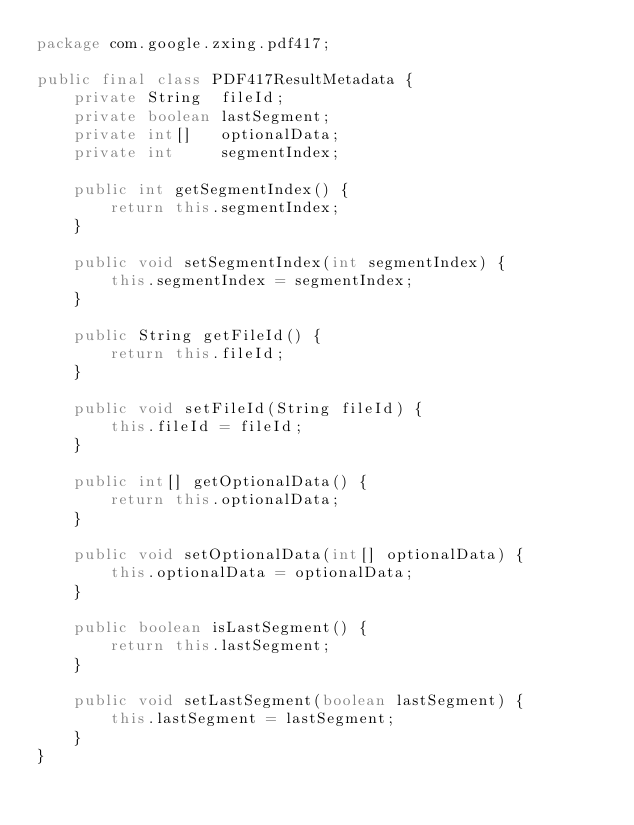Convert code to text. <code><loc_0><loc_0><loc_500><loc_500><_Java_>package com.google.zxing.pdf417;

public final class PDF417ResultMetadata {
    private String  fileId;
    private boolean lastSegment;
    private int[]   optionalData;
    private int     segmentIndex;

    public int getSegmentIndex() {
        return this.segmentIndex;
    }

    public void setSegmentIndex(int segmentIndex) {
        this.segmentIndex = segmentIndex;
    }

    public String getFileId() {
        return this.fileId;
    }

    public void setFileId(String fileId) {
        this.fileId = fileId;
    }

    public int[] getOptionalData() {
        return this.optionalData;
    }

    public void setOptionalData(int[] optionalData) {
        this.optionalData = optionalData;
    }

    public boolean isLastSegment() {
        return this.lastSegment;
    }

    public void setLastSegment(boolean lastSegment) {
        this.lastSegment = lastSegment;
    }
}
</code> 